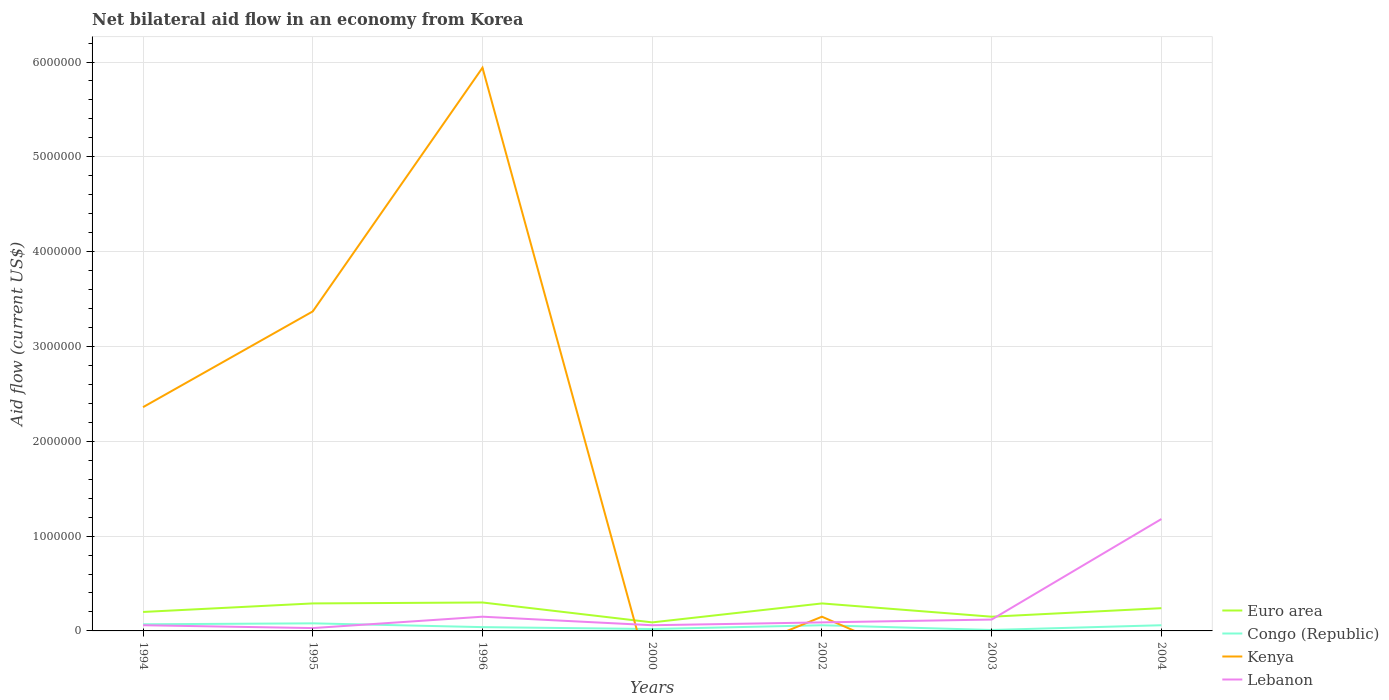Across all years, what is the maximum net bilateral aid flow in Euro area?
Your answer should be compact. 9.00e+04. What is the total net bilateral aid flow in Lebanon in the graph?
Keep it short and to the point. -1.06e+06. Is the net bilateral aid flow in Kenya strictly greater than the net bilateral aid flow in Lebanon over the years?
Your answer should be very brief. No. What is the difference between two consecutive major ticks on the Y-axis?
Make the answer very short. 1.00e+06. Are the values on the major ticks of Y-axis written in scientific E-notation?
Provide a succinct answer. No. Does the graph contain grids?
Your answer should be compact. Yes. Where does the legend appear in the graph?
Make the answer very short. Bottom right. How many legend labels are there?
Make the answer very short. 4. How are the legend labels stacked?
Provide a short and direct response. Vertical. What is the title of the graph?
Your answer should be compact. Net bilateral aid flow in an economy from Korea. What is the Aid flow (current US$) of Congo (Republic) in 1994?
Ensure brevity in your answer.  7.00e+04. What is the Aid flow (current US$) of Kenya in 1994?
Your response must be concise. 2.36e+06. What is the Aid flow (current US$) in Kenya in 1995?
Offer a terse response. 3.37e+06. What is the Aid flow (current US$) in Lebanon in 1995?
Your response must be concise. 3.00e+04. What is the Aid flow (current US$) of Euro area in 1996?
Offer a very short reply. 3.00e+05. What is the Aid flow (current US$) of Kenya in 1996?
Provide a short and direct response. 5.94e+06. What is the Aid flow (current US$) in Euro area in 2000?
Your answer should be compact. 9.00e+04. What is the Aid flow (current US$) of Congo (Republic) in 2000?
Your answer should be very brief. 2.00e+04. What is the Aid flow (current US$) in Lebanon in 2000?
Make the answer very short. 6.00e+04. What is the Aid flow (current US$) in Euro area in 2002?
Your response must be concise. 2.90e+05. What is the Aid flow (current US$) of Congo (Republic) in 2002?
Your answer should be compact. 6.00e+04. What is the Aid flow (current US$) in Kenya in 2002?
Ensure brevity in your answer.  1.50e+05. What is the Aid flow (current US$) in Lebanon in 2002?
Offer a terse response. 9.00e+04. What is the Aid flow (current US$) of Euro area in 2003?
Provide a succinct answer. 1.50e+05. What is the Aid flow (current US$) in Kenya in 2003?
Provide a short and direct response. 0. What is the Aid flow (current US$) in Kenya in 2004?
Provide a short and direct response. 0. What is the Aid flow (current US$) in Lebanon in 2004?
Give a very brief answer. 1.18e+06. Across all years, what is the maximum Aid flow (current US$) in Kenya?
Ensure brevity in your answer.  5.94e+06. Across all years, what is the maximum Aid flow (current US$) in Lebanon?
Give a very brief answer. 1.18e+06. Across all years, what is the minimum Aid flow (current US$) of Euro area?
Your answer should be very brief. 9.00e+04. What is the total Aid flow (current US$) in Euro area in the graph?
Ensure brevity in your answer.  1.56e+06. What is the total Aid flow (current US$) of Congo (Republic) in the graph?
Ensure brevity in your answer.  3.40e+05. What is the total Aid flow (current US$) of Kenya in the graph?
Your answer should be compact. 1.18e+07. What is the total Aid flow (current US$) of Lebanon in the graph?
Provide a succinct answer. 1.69e+06. What is the difference between the Aid flow (current US$) of Euro area in 1994 and that in 1995?
Ensure brevity in your answer.  -9.00e+04. What is the difference between the Aid flow (current US$) of Kenya in 1994 and that in 1995?
Offer a terse response. -1.01e+06. What is the difference between the Aid flow (current US$) in Euro area in 1994 and that in 1996?
Give a very brief answer. -1.00e+05. What is the difference between the Aid flow (current US$) in Kenya in 1994 and that in 1996?
Keep it short and to the point. -3.58e+06. What is the difference between the Aid flow (current US$) of Lebanon in 1994 and that in 1996?
Give a very brief answer. -9.00e+04. What is the difference between the Aid flow (current US$) of Euro area in 1994 and that in 2000?
Your response must be concise. 1.10e+05. What is the difference between the Aid flow (current US$) of Lebanon in 1994 and that in 2000?
Give a very brief answer. 0. What is the difference between the Aid flow (current US$) in Euro area in 1994 and that in 2002?
Your answer should be very brief. -9.00e+04. What is the difference between the Aid flow (current US$) of Congo (Republic) in 1994 and that in 2002?
Your answer should be compact. 10000. What is the difference between the Aid flow (current US$) in Kenya in 1994 and that in 2002?
Keep it short and to the point. 2.21e+06. What is the difference between the Aid flow (current US$) of Lebanon in 1994 and that in 2002?
Ensure brevity in your answer.  -3.00e+04. What is the difference between the Aid flow (current US$) of Congo (Republic) in 1994 and that in 2003?
Provide a short and direct response. 6.00e+04. What is the difference between the Aid flow (current US$) in Lebanon in 1994 and that in 2003?
Your response must be concise. -6.00e+04. What is the difference between the Aid flow (current US$) in Congo (Republic) in 1994 and that in 2004?
Your answer should be compact. 10000. What is the difference between the Aid flow (current US$) in Lebanon in 1994 and that in 2004?
Provide a short and direct response. -1.12e+06. What is the difference between the Aid flow (current US$) of Kenya in 1995 and that in 1996?
Your answer should be very brief. -2.57e+06. What is the difference between the Aid flow (current US$) in Congo (Republic) in 1995 and that in 2000?
Provide a succinct answer. 6.00e+04. What is the difference between the Aid flow (current US$) of Lebanon in 1995 and that in 2000?
Your response must be concise. -3.00e+04. What is the difference between the Aid flow (current US$) in Kenya in 1995 and that in 2002?
Make the answer very short. 3.22e+06. What is the difference between the Aid flow (current US$) of Lebanon in 1995 and that in 2002?
Give a very brief answer. -6.00e+04. What is the difference between the Aid flow (current US$) in Lebanon in 1995 and that in 2003?
Make the answer very short. -9.00e+04. What is the difference between the Aid flow (current US$) of Congo (Republic) in 1995 and that in 2004?
Keep it short and to the point. 2.00e+04. What is the difference between the Aid flow (current US$) of Lebanon in 1995 and that in 2004?
Provide a short and direct response. -1.15e+06. What is the difference between the Aid flow (current US$) in Congo (Republic) in 1996 and that in 2000?
Your answer should be very brief. 2.00e+04. What is the difference between the Aid flow (current US$) in Lebanon in 1996 and that in 2000?
Provide a short and direct response. 9.00e+04. What is the difference between the Aid flow (current US$) in Kenya in 1996 and that in 2002?
Your answer should be compact. 5.79e+06. What is the difference between the Aid flow (current US$) in Lebanon in 1996 and that in 2002?
Provide a short and direct response. 6.00e+04. What is the difference between the Aid flow (current US$) in Congo (Republic) in 1996 and that in 2003?
Keep it short and to the point. 3.00e+04. What is the difference between the Aid flow (current US$) in Euro area in 1996 and that in 2004?
Ensure brevity in your answer.  6.00e+04. What is the difference between the Aid flow (current US$) of Congo (Republic) in 1996 and that in 2004?
Offer a terse response. -2.00e+04. What is the difference between the Aid flow (current US$) in Lebanon in 1996 and that in 2004?
Provide a succinct answer. -1.03e+06. What is the difference between the Aid flow (current US$) of Euro area in 2000 and that in 2002?
Provide a succinct answer. -2.00e+05. What is the difference between the Aid flow (current US$) of Lebanon in 2000 and that in 2002?
Make the answer very short. -3.00e+04. What is the difference between the Aid flow (current US$) in Congo (Republic) in 2000 and that in 2004?
Make the answer very short. -4.00e+04. What is the difference between the Aid flow (current US$) in Lebanon in 2000 and that in 2004?
Your answer should be very brief. -1.12e+06. What is the difference between the Aid flow (current US$) in Congo (Republic) in 2002 and that in 2003?
Keep it short and to the point. 5.00e+04. What is the difference between the Aid flow (current US$) in Euro area in 2002 and that in 2004?
Provide a short and direct response. 5.00e+04. What is the difference between the Aid flow (current US$) in Congo (Republic) in 2002 and that in 2004?
Provide a short and direct response. 0. What is the difference between the Aid flow (current US$) of Lebanon in 2002 and that in 2004?
Keep it short and to the point. -1.09e+06. What is the difference between the Aid flow (current US$) of Congo (Republic) in 2003 and that in 2004?
Your answer should be compact. -5.00e+04. What is the difference between the Aid flow (current US$) of Lebanon in 2003 and that in 2004?
Give a very brief answer. -1.06e+06. What is the difference between the Aid flow (current US$) of Euro area in 1994 and the Aid flow (current US$) of Kenya in 1995?
Ensure brevity in your answer.  -3.17e+06. What is the difference between the Aid flow (current US$) in Congo (Republic) in 1994 and the Aid flow (current US$) in Kenya in 1995?
Provide a succinct answer. -3.30e+06. What is the difference between the Aid flow (current US$) in Congo (Republic) in 1994 and the Aid flow (current US$) in Lebanon in 1995?
Your answer should be very brief. 4.00e+04. What is the difference between the Aid flow (current US$) of Kenya in 1994 and the Aid flow (current US$) of Lebanon in 1995?
Your answer should be compact. 2.33e+06. What is the difference between the Aid flow (current US$) in Euro area in 1994 and the Aid flow (current US$) in Congo (Republic) in 1996?
Provide a short and direct response. 1.60e+05. What is the difference between the Aid flow (current US$) in Euro area in 1994 and the Aid flow (current US$) in Kenya in 1996?
Provide a succinct answer. -5.74e+06. What is the difference between the Aid flow (current US$) in Congo (Republic) in 1994 and the Aid flow (current US$) in Kenya in 1996?
Your answer should be compact. -5.87e+06. What is the difference between the Aid flow (current US$) in Kenya in 1994 and the Aid flow (current US$) in Lebanon in 1996?
Provide a succinct answer. 2.21e+06. What is the difference between the Aid flow (current US$) in Euro area in 1994 and the Aid flow (current US$) in Congo (Republic) in 2000?
Give a very brief answer. 1.80e+05. What is the difference between the Aid flow (current US$) in Euro area in 1994 and the Aid flow (current US$) in Lebanon in 2000?
Give a very brief answer. 1.40e+05. What is the difference between the Aid flow (current US$) of Kenya in 1994 and the Aid flow (current US$) of Lebanon in 2000?
Your answer should be very brief. 2.30e+06. What is the difference between the Aid flow (current US$) of Euro area in 1994 and the Aid flow (current US$) of Congo (Republic) in 2002?
Ensure brevity in your answer.  1.40e+05. What is the difference between the Aid flow (current US$) in Congo (Republic) in 1994 and the Aid flow (current US$) in Kenya in 2002?
Your response must be concise. -8.00e+04. What is the difference between the Aid flow (current US$) in Congo (Republic) in 1994 and the Aid flow (current US$) in Lebanon in 2002?
Your answer should be compact. -2.00e+04. What is the difference between the Aid flow (current US$) in Kenya in 1994 and the Aid flow (current US$) in Lebanon in 2002?
Ensure brevity in your answer.  2.27e+06. What is the difference between the Aid flow (current US$) in Euro area in 1994 and the Aid flow (current US$) in Lebanon in 2003?
Offer a very short reply. 8.00e+04. What is the difference between the Aid flow (current US$) of Congo (Republic) in 1994 and the Aid flow (current US$) of Lebanon in 2003?
Give a very brief answer. -5.00e+04. What is the difference between the Aid flow (current US$) in Kenya in 1994 and the Aid flow (current US$) in Lebanon in 2003?
Your response must be concise. 2.24e+06. What is the difference between the Aid flow (current US$) in Euro area in 1994 and the Aid flow (current US$) in Lebanon in 2004?
Make the answer very short. -9.80e+05. What is the difference between the Aid flow (current US$) of Congo (Republic) in 1994 and the Aid flow (current US$) of Lebanon in 2004?
Your answer should be very brief. -1.11e+06. What is the difference between the Aid flow (current US$) in Kenya in 1994 and the Aid flow (current US$) in Lebanon in 2004?
Your answer should be compact. 1.18e+06. What is the difference between the Aid flow (current US$) of Euro area in 1995 and the Aid flow (current US$) of Kenya in 1996?
Keep it short and to the point. -5.65e+06. What is the difference between the Aid flow (current US$) of Congo (Republic) in 1995 and the Aid flow (current US$) of Kenya in 1996?
Provide a short and direct response. -5.86e+06. What is the difference between the Aid flow (current US$) in Congo (Republic) in 1995 and the Aid flow (current US$) in Lebanon in 1996?
Your answer should be compact. -7.00e+04. What is the difference between the Aid flow (current US$) of Kenya in 1995 and the Aid flow (current US$) of Lebanon in 1996?
Provide a succinct answer. 3.22e+06. What is the difference between the Aid flow (current US$) in Euro area in 1995 and the Aid flow (current US$) in Congo (Republic) in 2000?
Keep it short and to the point. 2.70e+05. What is the difference between the Aid flow (current US$) in Euro area in 1995 and the Aid flow (current US$) in Lebanon in 2000?
Provide a short and direct response. 2.30e+05. What is the difference between the Aid flow (current US$) of Kenya in 1995 and the Aid flow (current US$) of Lebanon in 2000?
Give a very brief answer. 3.31e+06. What is the difference between the Aid flow (current US$) of Euro area in 1995 and the Aid flow (current US$) of Congo (Republic) in 2002?
Your answer should be compact. 2.30e+05. What is the difference between the Aid flow (current US$) in Congo (Republic) in 1995 and the Aid flow (current US$) in Kenya in 2002?
Give a very brief answer. -7.00e+04. What is the difference between the Aid flow (current US$) in Kenya in 1995 and the Aid flow (current US$) in Lebanon in 2002?
Ensure brevity in your answer.  3.28e+06. What is the difference between the Aid flow (current US$) of Euro area in 1995 and the Aid flow (current US$) of Congo (Republic) in 2003?
Make the answer very short. 2.80e+05. What is the difference between the Aid flow (current US$) in Congo (Republic) in 1995 and the Aid flow (current US$) in Lebanon in 2003?
Offer a very short reply. -4.00e+04. What is the difference between the Aid flow (current US$) in Kenya in 1995 and the Aid flow (current US$) in Lebanon in 2003?
Offer a terse response. 3.25e+06. What is the difference between the Aid flow (current US$) of Euro area in 1995 and the Aid flow (current US$) of Congo (Republic) in 2004?
Make the answer very short. 2.30e+05. What is the difference between the Aid flow (current US$) in Euro area in 1995 and the Aid flow (current US$) in Lebanon in 2004?
Offer a very short reply. -8.90e+05. What is the difference between the Aid flow (current US$) of Congo (Republic) in 1995 and the Aid flow (current US$) of Lebanon in 2004?
Provide a short and direct response. -1.10e+06. What is the difference between the Aid flow (current US$) of Kenya in 1995 and the Aid flow (current US$) of Lebanon in 2004?
Your answer should be very brief. 2.19e+06. What is the difference between the Aid flow (current US$) of Euro area in 1996 and the Aid flow (current US$) of Lebanon in 2000?
Keep it short and to the point. 2.40e+05. What is the difference between the Aid flow (current US$) of Kenya in 1996 and the Aid flow (current US$) of Lebanon in 2000?
Offer a terse response. 5.88e+06. What is the difference between the Aid flow (current US$) of Euro area in 1996 and the Aid flow (current US$) of Congo (Republic) in 2002?
Provide a short and direct response. 2.40e+05. What is the difference between the Aid flow (current US$) in Euro area in 1996 and the Aid flow (current US$) in Kenya in 2002?
Ensure brevity in your answer.  1.50e+05. What is the difference between the Aid flow (current US$) of Congo (Republic) in 1996 and the Aid flow (current US$) of Kenya in 2002?
Offer a very short reply. -1.10e+05. What is the difference between the Aid flow (current US$) in Congo (Republic) in 1996 and the Aid flow (current US$) in Lebanon in 2002?
Keep it short and to the point. -5.00e+04. What is the difference between the Aid flow (current US$) in Kenya in 1996 and the Aid flow (current US$) in Lebanon in 2002?
Provide a short and direct response. 5.85e+06. What is the difference between the Aid flow (current US$) in Euro area in 1996 and the Aid flow (current US$) in Congo (Republic) in 2003?
Offer a terse response. 2.90e+05. What is the difference between the Aid flow (current US$) in Euro area in 1996 and the Aid flow (current US$) in Lebanon in 2003?
Offer a very short reply. 1.80e+05. What is the difference between the Aid flow (current US$) of Congo (Republic) in 1996 and the Aid flow (current US$) of Lebanon in 2003?
Give a very brief answer. -8.00e+04. What is the difference between the Aid flow (current US$) in Kenya in 1996 and the Aid flow (current US$) in Lebanon in 2003?
Make the answer very short. 5.82e+06. What is the difference between the Aid flow (current US$) in Euro area in 1996 and the Aid flow (current US$) in Lebanon in 2004?
Keep it short and to the point. -8.80e+05. What is the difference between the Aid flow (current US$) in Congo (Republic) in 1996 and the Aid flow (current US$) in Lebanon in 2004?
Keep it short and to the point. -1.14e+06. What is the difference between the Aid flow (current US$) in Kenya in 1996 and the Aid flow (current US$) in Lebanon in 2004?
Provide a succinct answer. 4.76e+06. What is the difference between the Aid flow (current US$) of Euro area in 2000 and the Aid flow (current US$) of Congo (Republic) in 2002?
Provide a short and direct response. 3.00e+04. What is the difference between the Aid flow (current US$) in Euro area in 2000 and the Aid flow (current US$) in Kenya in 2002?
Make the answer very short. -6.00e+04. What is the difference between the Aid flow (current US$) in Euro area in 2000 and the Aid flow (current US$) in Lebanon in 2002?
Provide a succinct answer. 0. What is the difference between the Aid flow (current US$) in Congo (Republic) in 2000 and the Aid flow (current US$) in Kenya in 2002?
Your answer should be very brief. -1.30e+05. What is the difference between the Aid flow (current US$) in Congo (Republic) in 2000 and the Aid flow (current US$) in Lebanon in 2002?
Offer a terse response. -7.00e+04. What is the difference between the Aid flow (current US$) in Euro area in 2000 and the Aid flow (current US$) in Lebanon in 2004?
Your answer should be compact. -1.09e+06. What is the difference between the Aid flow (current US$) of Congo (Republic) in 2000 and the Aid flow (current US$) of Lebanon in 2004?
Your answer should be compact. -1.16e+06. What is the difference between the Aid flow (current US$) of Euro area in 2002 and the Aid flow (current US$) of Lebanon in 2003?
Ensure brevity in your answer.  1.70e+05. What is the difference between the Aid flow (current US$) in Congo (Republic) in 2002 and the Aid flow (current US$) in Lebanon in 2003?
Provide a succinct answer. -6.00e+04. What is the difference between the Aid flow (current US$) in Kenya in 2002 and the Aid flow (current US$) in Lebanon in 2003?
Make the answer very short. 3.00e+04. What is the difference between the Aid flow (current US$) of Euro area in 2002 and the Aid flow (current US$) of Lebanon in 2004?
Your response must be concise. -8.90e+05. What is the difference between the Aid flow (current US$) of Congo (Republic) in 2002 and the Aid flow (current US$) of Lebanon in 2004?
Offer a very short reply. -1.12e+06. What is the difference between the Aid flow (current US$) in Kenya in 2002 and the Aid flow (current US$) in Lebanon in 2004?
Provide a short and direct response. -1.03e+06. What is the difference between the Aid flow (current US$) in Euro area in 2003 and the Aid flow (current US$) in Lebanon in 2004?
Ensure brevity in your answer.  -1.03e+06. What is the difference between the Aid flow (current US$) in Congo (Republic) in 2003 and the Aid flow (current US$) in Lebanon in 2004?
Your answer should be very brief. -1.17e+06. What is the average Aid flow (current US$) of Euro area per year?
Make the answer very short. 2.23e+05. What is the average Aid flow (current US$) in Congo (Republic) per year?
Provide a succinct answer. 4.86e+04. What is the average Aid flow (current US$) in Kenya per year?
Your answer should be very brief. 1.69e+06. What is the average Aid flow (current US$) in Lebanon per year?
Your response must be concise. 2.41e+05. In the year 1994, what is the difference between the Aid flow (current US$) of Euro area and Aid flow (current US$) of Congo (Republic)?
Offer a very short reply. 1.30e+05. In the year 1994, what is the difference between the Aid flow (current US$) in Euro area and Aid flow (current US$) in Kenya?
Your answer should be compact. -2.16e+06. In the year 1994, what is the difference between the Aid flow (current US$) in Congo (Republic) and Aid flow (current US$) in Kenya?
Provide a succinct answer. -2.29e+06. In the year 1994, what is the difference between the Aid flow (current US$) in Kenya and Aid flow (current US$) in Lebanon?
Offer a terse response. 2.30e+06. In the year 1995, what is the difference between the Aid flow (current US$) of Euro area and Aid flow (current US$) of Congo (Republic)?
Keep it short and to the point. 2.10e+05. In the year 1995, what is the difference between the Aid flow (current US$) of Euro area and Aid flow (current US$) of Kenya?
Provide a short and direct response. -3.08e+06. In the year 1995, what is the difference between the Aid flow (current US$) in Congo (Republic) and Aid flow (current US$) in Kenya?
Keep it short and to the point. -3.29e+06. In the year 1995, what is the difference between the Aid flow (current US$) of Kenya and Aid flow (current US$) of Lebanon?
Offer a very short reply. 3.34e+06. In the year 1996, what is the difference between the Aid flow (current US$) of Euro area and Aid flow (current US$) of Kenya?
Offer a very short reply. -5.64e+06. In the year 1996, what is the difference between the Aid flow (current US$) of Congo (Republic) and Aid flow (current US$) of Kenya?
Offer a very short reply. -5.90e+06. In the year 1996, what is the difference between the Aid flow (current US$) of Kenya and Aid flow (current US$) of Lebanon?
Your answer should be compact. 5.79e+06. In the year 2000, what is the difference between the Aid flow (current US$) of Congo (Republic) and Aid flow (current US$) of Lebanon?
Provide a succinct answer. -4.00e+04. In the year 2002, what is the difference between the Aid flow (current US$) in Euro area and Aid flow (current US$) in Congo (Republic)?
Your answer should be compact. 2.30e+05. In the year 2002, what is the difference between the Aid flow (current US$) of Euro area and Aid flow (current US$) of Kenya?
Your response must be concise. 1.40e+05. In the year 2002, what is the difference between the Aid flow (current US$) of Congo (Republic) and Aid flow (current US$) of Kenya?
Your response must be concise. -9.00e+04. In the year 2002, what is the difference between the Aid flow (current US$) in Congo (Republic) and Aid flow (current US$) in Lebanon?
Give a very brief answer. -3.00e+04. In the year 2004, what is the difference between the Aid flow (current US$) in Euro area and Aid flow (current US$) in Congo (Republic)?
Ensure brevity in your answer.  1.80e+05. In the year 2004, what is the difference between the Aid flow (current US$) in Euro area and Aid flow (current US$) in Lebanon?
Provide a succinct answer. -9.40e+05. In the year 2004, what is the difference between the Aid flow (current US$) of Congo (Republic) and Aid flow (current US$) of Lebanon?
Offer a very short reply. -1.12e+06. What is the ratio of the Aid flow (current US$) of Euro area in 1994 to that in 1995?
Your answer should be very brief. 0.69. What is the ratio of the Aid flow (current US$) in Congo (Republic) in 1994 to that in 1995?
Provide a succinct answer. 0.88. What is the ratio of the Aid flow (current US$) in Kenya in 1994 to that in 1995?
Offer a very short reply. 0.7. What is the ratio of the Aid flow (current US$) of Euro area in 1994 to that in 1996?
Make the answer very short. 0.67. What is the ratio of the Aid flow (current US$) in Congo (Republic) in 1994 to that in 1996?
Offer a terse response. 1.75. What is the ratio of the Aid flow (current US$) of Kenya in 1994 to that in 1996?
Keep it short and to the point. 0.4. What is the ratio of the Aid flow (current US$) of Euro area in 1994 to that in 2000?
Provide a short and direct response. 2.22. What is the ratio of the Aid flow (current US$) in Congo (Republic) in 1994 to that in 2000?
Keep it short and to the point. 3.5. What is the ratio of the Aid flow (current US$) of Euro area in 1994 to that in 2002?
Provide a succinct answer. 0.69. What is the ratio of the Aid flow (current US$) of Congo (Republic) in 1994 to that in 2002?
Provide a short and direct response. 1.17. What is the ratio of the Aid flow (current US$) of Kenya in 1994 to that in 2002?
Keep it short and to the point. 15.73. What is the ratio of the Aid flow (current US$) in Lebanon in 1994 to that in 2002?
Offer a terse response. 0.67. What is the ratio of the Aid flow (current US$) in Congo (Republic) in 1994 to that in 2003?
Keep it short and to the point. 7. What is the ratio of the Aid flow (current US$) of Euro area in 1994 to that in 2004?
Your answer should be very brief. 0.83. What is the ratio of the Aid flow (current US$) in Lebanon in 1994 to that in 2004?
Offer a terse response. 0.05. What is the ratio of the Aid flow (current US$) of Euro area in 1995 to that in 1996?
Offer a terse response. 0.97. What is the ratio of the Aid flow (current US$) in Congo (Republic) in 1995 to that in 1996?
Your response must be concise. 2. What is the ratio of the Aid flow (current US$) of Kenya in 1995 to that in 1996?
Provide a succinct answer. 0.57. What is the ratio of the Aid flow (current US$) of Euro area in 1995 to that in 2000?
Offer a terse response. 3.22. What is the ratio of the Aid flow (current US$) in Congo (Republic) in 1995 to that in 2000?
Ensure brevity in your answer.  4. What is the ratio of the Aid flow (current US$) of Lebanon in 1995 to that in 2000?
Provide a succinct answer. 0.5. What is the ratio of the Aid flow (current US$) of Congo (Republic) in 1995 to that in 2002?
Your answer should be very brief. 1.33. What is the ratio of the Aid flow (current US$) in Kenya in 1995 to that in 2002?
Your answer should be compact. 22.47. What is the ratio of the Aid flow (current US$) of Lebanon in 1995 to that in 2002?
Keep it short and to the point. 0.33. What is the ratio of the Aid flow (current US$) in Euro area in 1995 to that in 2003?
Keep it short and to the point. 1.93. What is the ratio of the Aid flow (current US$) of Congo (Republic) in 1995 to that in 2003?
Give a very brief answer. 8. What is the ratio of the Aid flow (current US$) in Lebanon in 1995 to that in 2003?
Your answer should be very brief. 0.25. What is the ratio of the Aid flow (current US$) of Euro area in 1995 to that in 2004?
Make the answer very short. 1.21. What is the ratio of the Aid flow (current US$) in Lebanon in 1995 to that in 2004?
Your response must be concise. 0.03. What is the ratio of the Aid flow (current US$) of Euro area in 1996 to that in 2002?
Offer a very short reply. 1.03. What is the ratio of the Aid flow (current US$) of Congo (Republic) in 1996 to that in 2002?
Your answer should be very brief. 0.67. What is the ratio of the Aid flow (current US$) of Kenya in 1996 to that in 2002?
Your answer should be compact. 39.6. What is the ratio of the Aid flow (current US$) in Lebanon in 1996 to that in 2002?
Provide a short and direct response. 1.67. What is the ratio of the Aid flow (current US$) in Euro area in 1996 to that in 2003?
Your answer should be very brief. 2. What is the ratio of the Aid flow (current US$) in Lebanon in 1996 to that in 2003?
Provide a succinct answer. 1.25. What is the ratio of the Aid flow (current US$) in Lebanon in 1996 to that in 2004?
Give a very brief answer. 0.13. What is the ratio of the Aid flow (current US$) of Euro area in 2000 to that in 2002?
Your answer should be compact. 0.31. What is the ratio of the Aid flow (current US$) of Euro area in 2000 to that in 2003?
Make the answer very short. 0.6. What is the ratio of the Aid flow (current US$) in Euro area in 2000 to that in 2004?
Provide a succinct answer. 0.38. What is the ratio of the Aid flow (current US$) in Lebanon in 2000 to that in 2004?
Give a very brief answer. 0.05. What is the ratio of the Aid flow (current US$) in Euro area in 2002 to that in 2003?
Provide a short and direct response. 1.93. What is the ratio of the Aid flow (current US$) in Congo (Republic) in 2002 to that in 2003?
Make the answer very short. 6. What is the ratio of the Aid flow (current US$) in Lebanon in 2002 to that in 2003?
Give a very brief answer. 0.75. What is the ratio of the Aid flow (current US$) of Euro area in 2002 to that in 2004?
Your answer should be compact. 1.21. What is the ratio of the Aid flow (current US$) in Congo (Republic) in 2002 to that in 2004?
Provide a succinct answer. 1. What is the ratio of the Aid flow (current US$) of Lebanon in 2002 to that in 2004?
Offer a very short reply. 0.08. What is the ratio of the Aid flow (current US$) in Euro area in 2003 to that in 2004?
Offer a very short reply. 0.62. What is the ratio of the Aid flow (current US$) of Congo (Republic) in 2003 to that in 2004?
Give a very brief answer. 0.17. What is the ratio of the Aid flow (current US$) in Lebanon in 2003 to that in 2004?
Provide a succinct answer. 0.1. What is the difference between the highest and the second highest Aid flow (current US$) of Kenya?
Your answer should be compact. 2.57e+06. What is the difference between the highest and the second highest Aid flow (current US$) in Lebanon?
Your response must be concise. 1.03e+06. What is the difference between the highest and the lowest Aid flow (current US$) of Kenya?
Ensure brevity in your answer.  5.94e+06. What is the difference between the highest and the lowest Aid flow (current US$) of Lebanon?
Offer a terse response. 1.15e+06. 